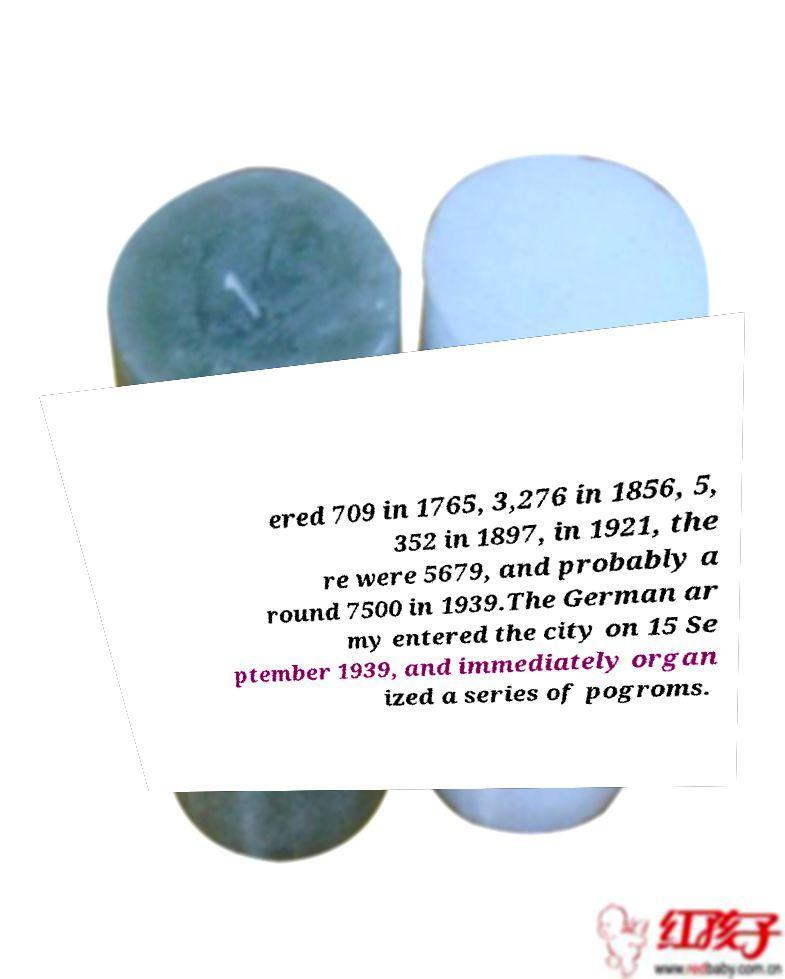I need the written content from this picture converted into text. Can you do that? ered 709 in 1765, 3,276 in 1856, 5, 352 in 1897, in 1921, the re were 5679, and probably a round 7500 in 1939.The German ar my entered the city on 15 Se ptember 1939, and immediately organ ized a series of pogroms. 